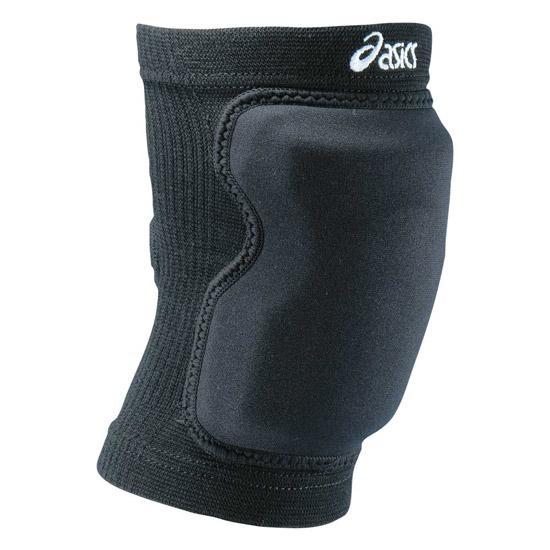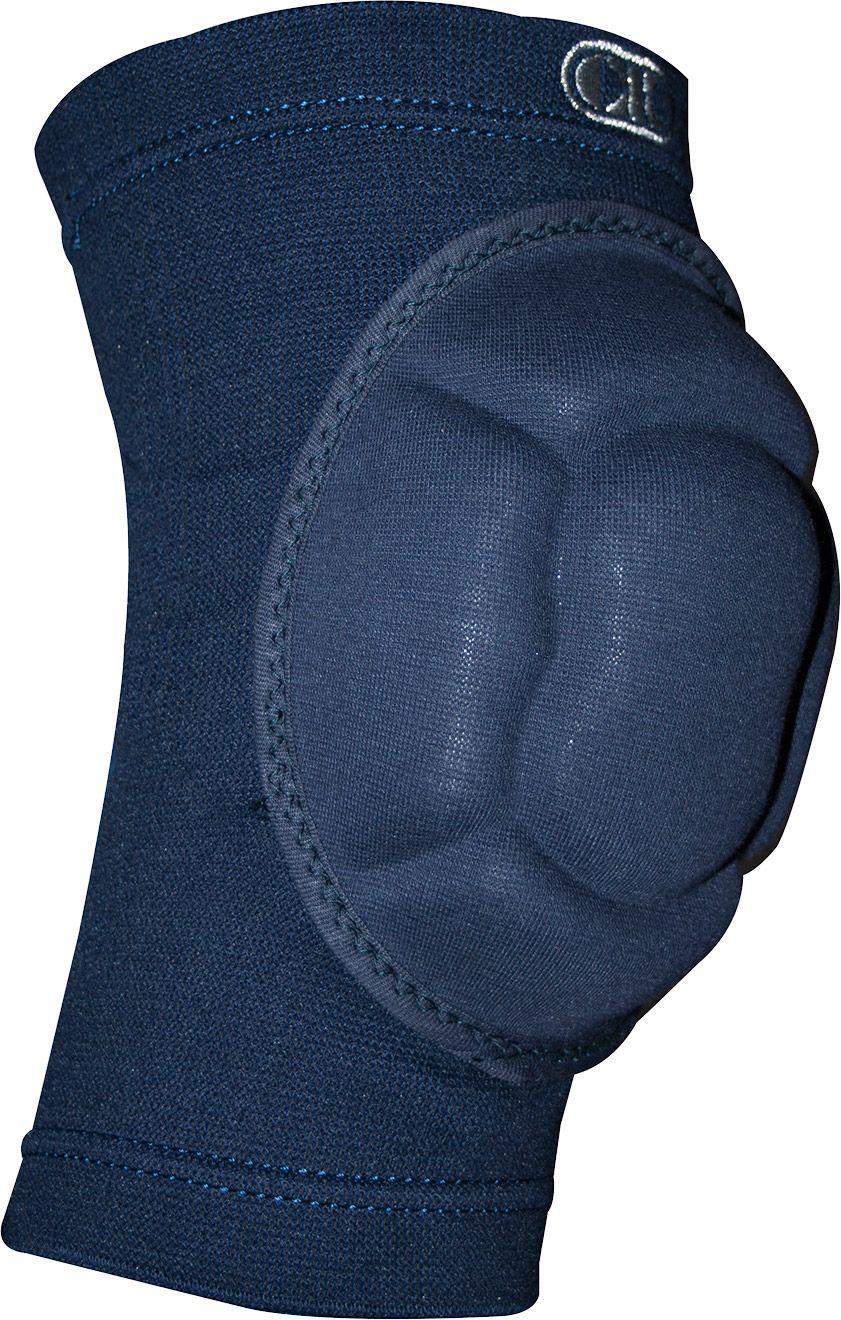The first image is the image on the left, the second image is the image on the right. For the images shown, is this caption "The item in the image on the left is facing forward." true? Answer yes or no. No. 